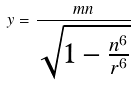<formula> <loc_0><loc_0><loc_500><loc_500>y = \frac { m n } { \sqrt { 1 - \frac { n ^ { 6 } } { r ^ { 6 } } } }</formula> 